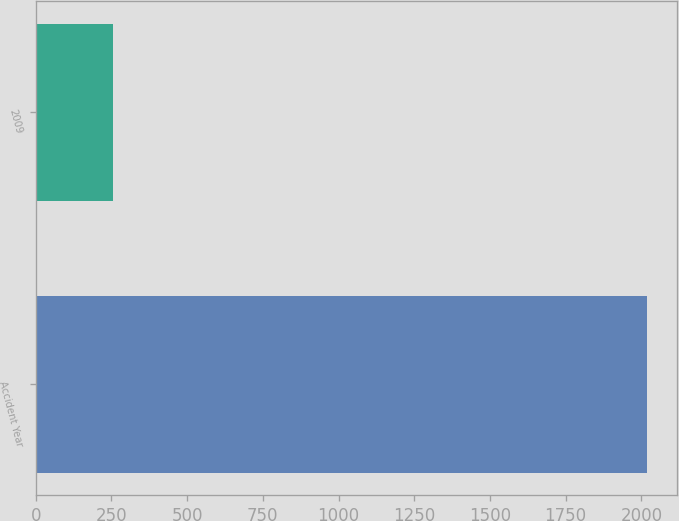Convert chart. <chart><loc_0><loc_0><loc_500><loc_500><bar_chart><fcel>Accident Year<fcel>2009<nl><fcel>2017<fcel>257<nl></chart> 